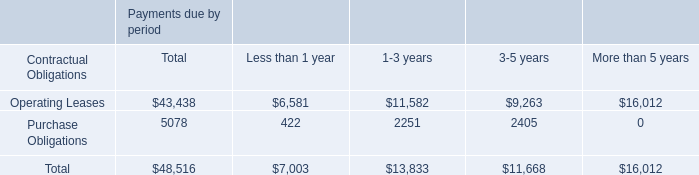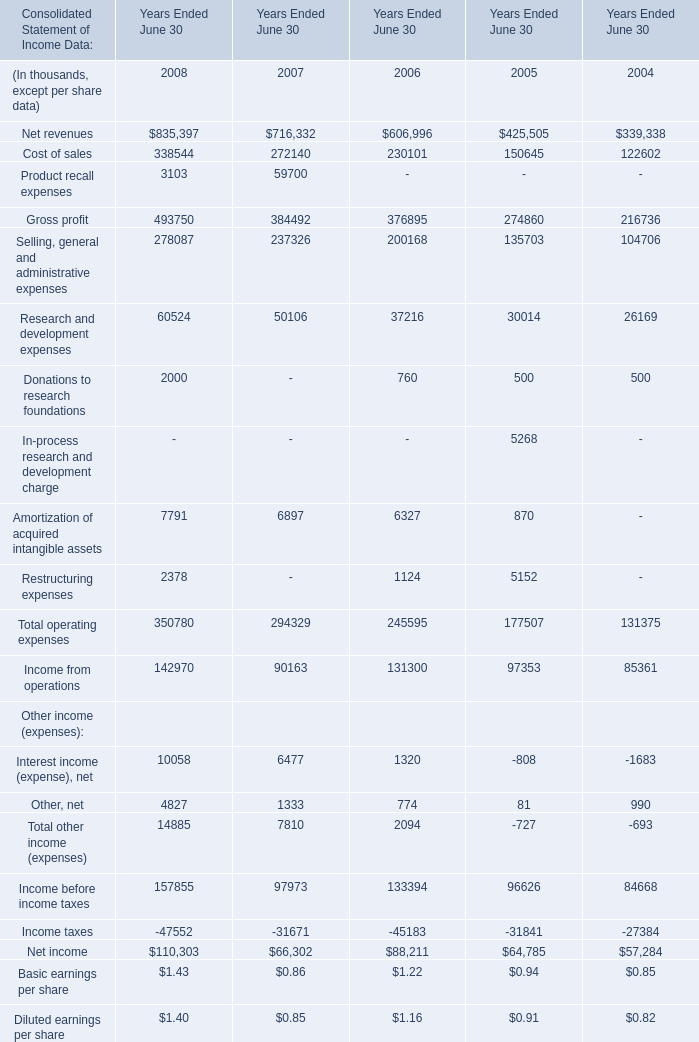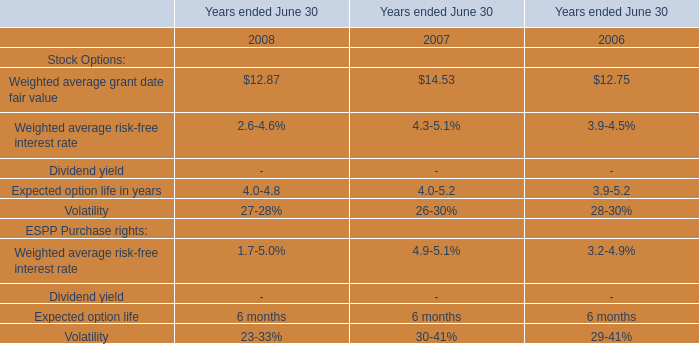What is the sum ofGross profit in the range of 1 and 500000 in 2008 and 2007? (in thousand) 
Computations: (493750 + 384492)
Answer: 878242.0. 